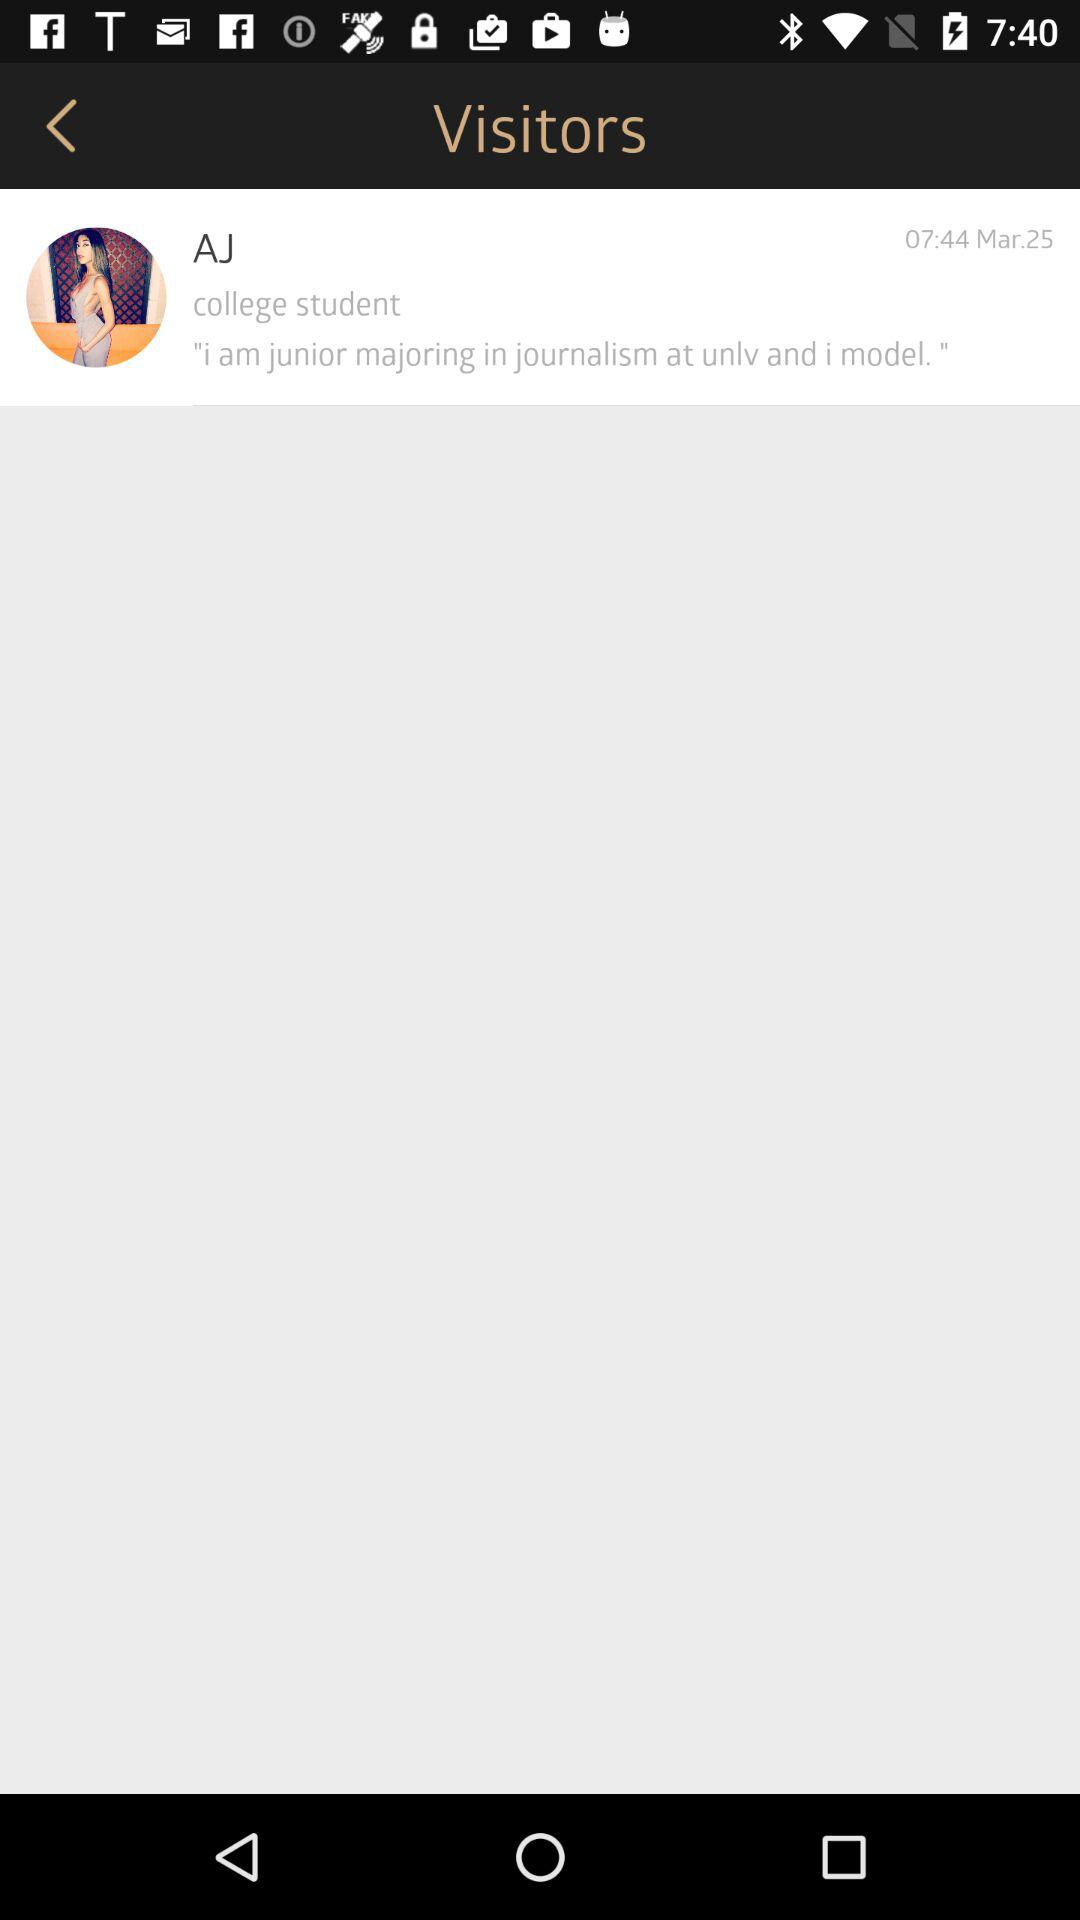What is the name? The name is "AJ". 